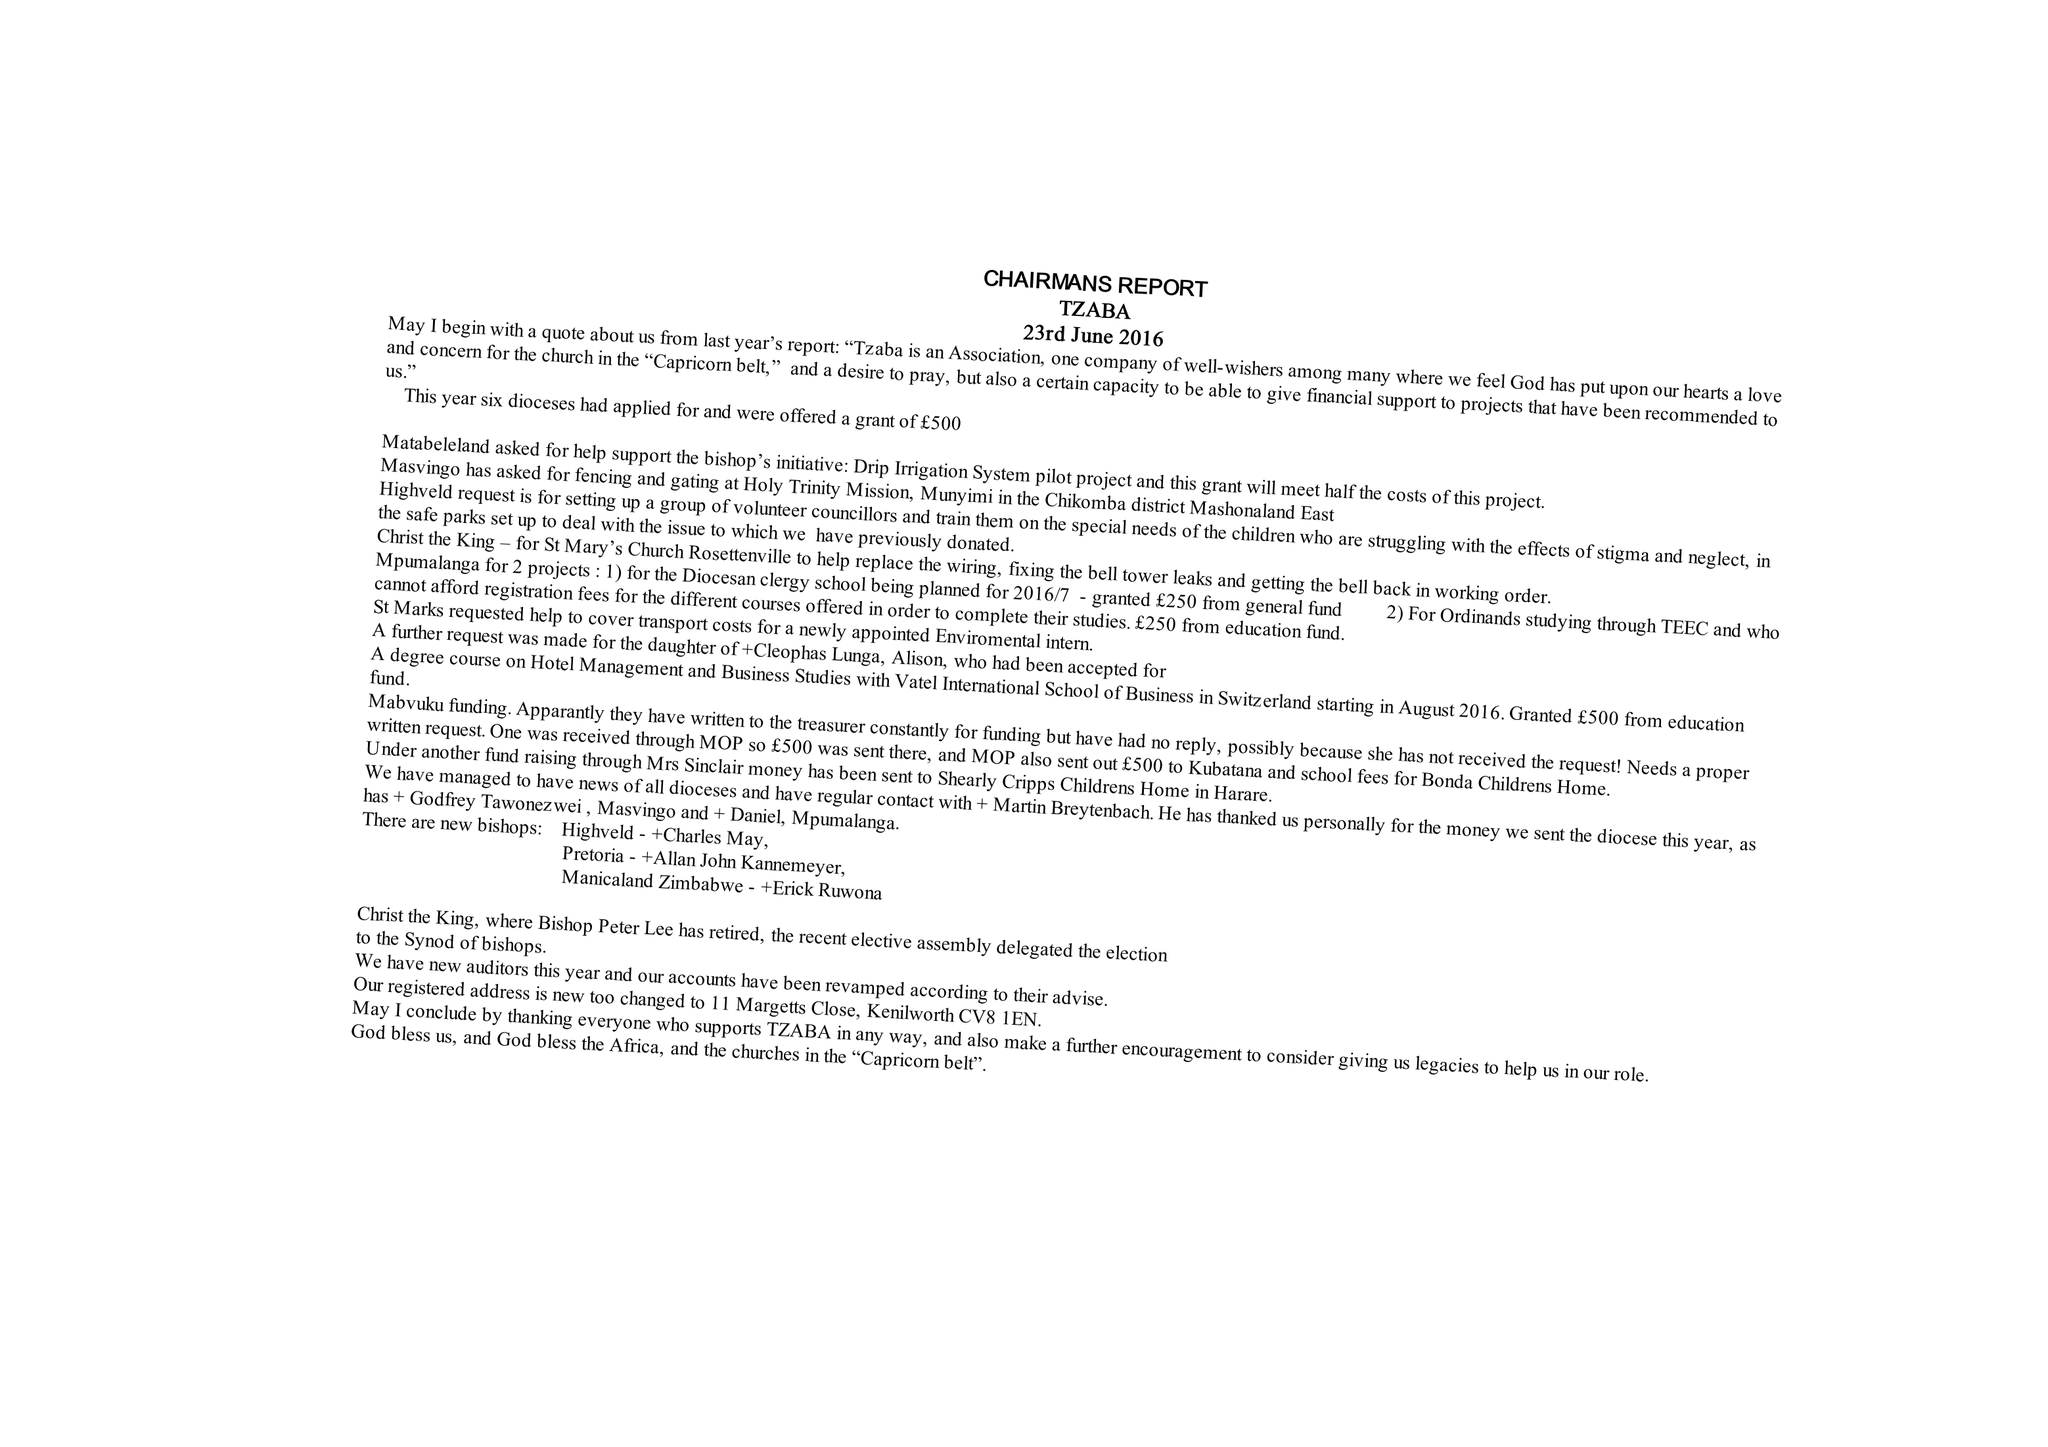What is the value for the address__street_line?
Answer the question using a single word or phrase. 11 MARGETTS CLOSE 